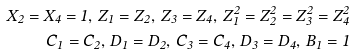Convert formula to latex. <formula><loc_0><loc_0><loc_500><loc_500>X _ { 2 } = X _ { 4 } = 1 , \, Z _ { 1 } = Z _ { 2 } , \, Z _ { 3 } = Z _ { 4 } , \, Z _ { 1 } ^ { 2 } = Z _ { 2 } ^ { 2 } = Z _ { 3 } ^ { 2 } = Z _ { 4 } ^ { 2 } \\ C _ { 1 } = C _ { 2 } , \, D _ { 1 } = D _ { 2 } , \, C _ { 3 } = C _ { 4 } , \, D _ { 3 } = D _ { 4 } , \, B _ { 1 } = 1</formula> 